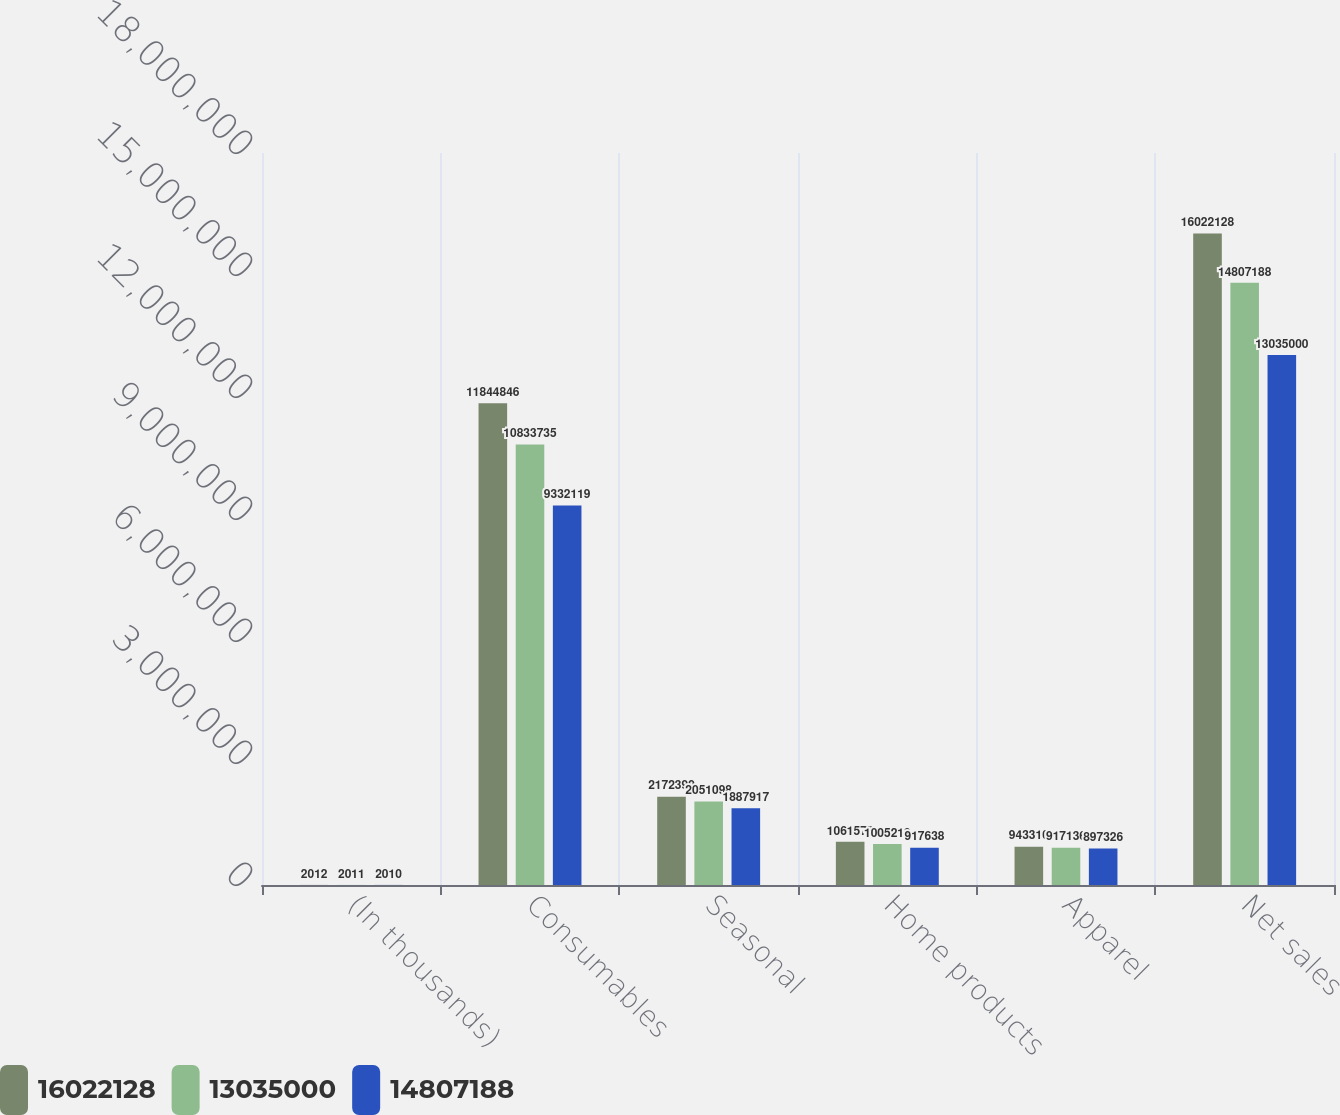Convert chart to OTSL. <chart><loc_0><loc_0><loc_500><loc_500><stacked_bar_chart><ecel><fcel>(In thousands)<fcel>Consumables<fcel>Seasonal<fcel>Home products<fcel>Apparel<fcel>Net sales<nl><fcel>1.60221e+07<fcel>2012<fcel>1.18448e+07<fcel>2.1724e+06<fcel>1.06157e+06<fcel>943310<fcel>1.60221e+07<nl><fcel>1.3035e+07<fcel>2011<fcel>1.08337e+07<fcel>2.0511e+06<fcel>1.00522e+06<fcel>917136<fcel>1.48072e+07<nl><fcel>1.48072e+07<fcel>2010<fcel>9.33212e+06<fcel>1.88792e+06<fcel>917638<fcel>897326<fcel>1.3035e+07<nl></chart> 